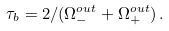Convert formula to latex. <formula><loc_0><loc_0><loc_500><loc_500>\tau _ { b } = 2 / ( \Omega _ { - } ^ { o u t } + \Omega _ { + } ^ { o u t } ) \, .</formula> 